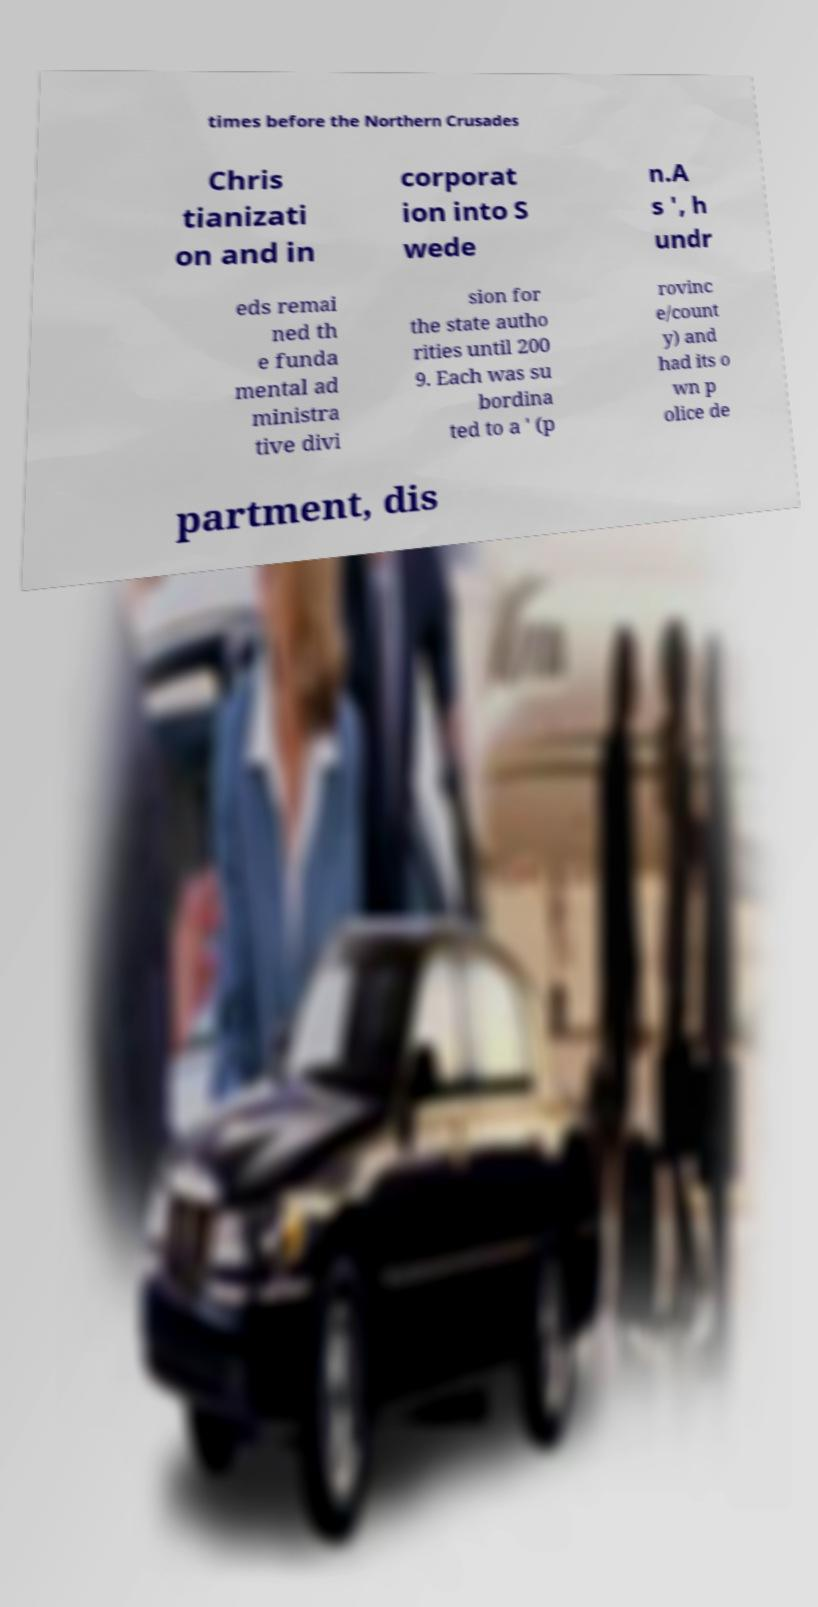There's text embedded in this image that I need extracted. Can you transcribe it verbatim? times before the Northern Crusades Chris tianizati on and in corporat ion into S wede n.A s ', h undr eds remai ned th e funda mental ad ministra tive divi sion for the state autho rities until 200 9. Each was su bordina ted to a ' (p rovinc e/count y) and had its o wn p olice de partment, dis 